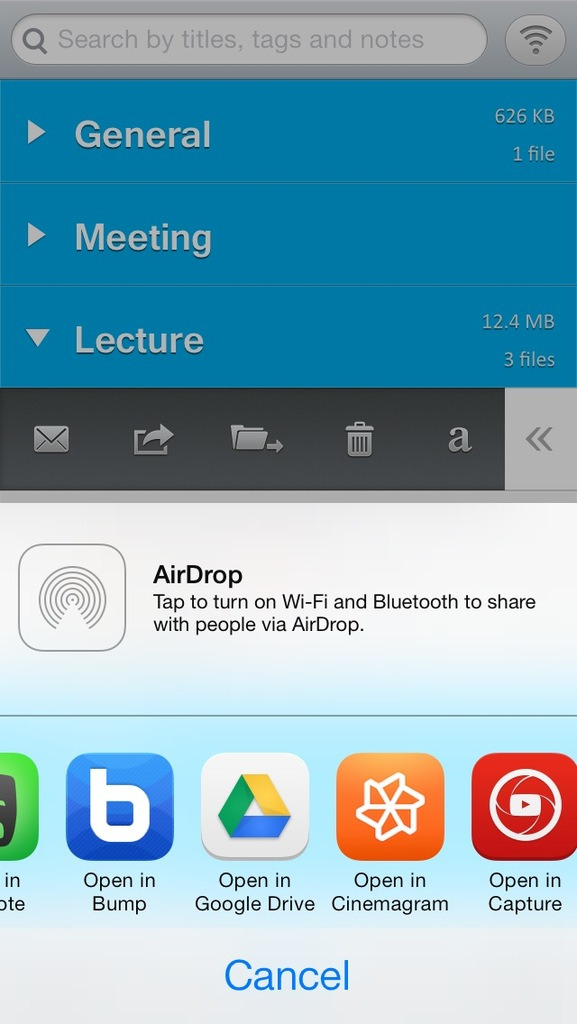What types of content might be stored in the folders labeled 'General', 'Meeting', and 'Lecture'? The 'General' folder likely contains miscellaneous files, the 'Meeting' folder could store documents and notes from specific meetings, and the 'Lecture' folder might hold presentations or academic materials related to lectures. 